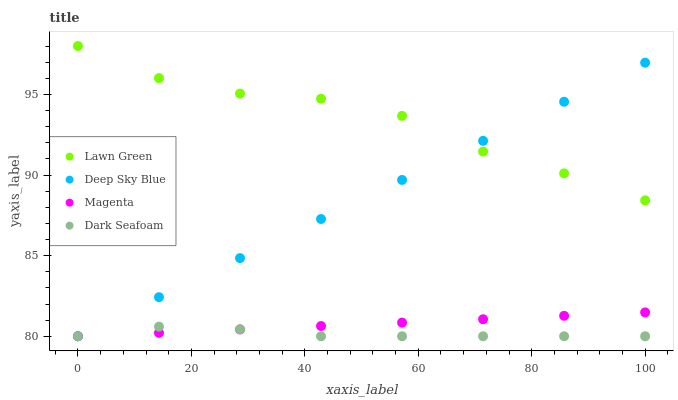Does Dark Seafoam have the minimum area under the curve?
Answer yes or no. Yes. Does Lawn Green have the maximum area under the curve?
Answer yes or no. Yes. Does Magenta have the minimum area under the curve?
Answer yes or no. No. Does Magenta have the maximum area under the curve?
Answer yes or no. No. Is Deep Sky Blue the smoothest?
Answer yes or no. Yes. Is Lawn Green the roughest?
Answer yes or no. Yes. Is Magenta the smoothest?
Answer yes or no. No. Is Magenta the roughest?
Answer yes or no. No. Does Magenta have the lowest value?
Answer yes or no. Yes. Does Lawn Green have the highest value?
Answer yes or no. Yes. Does Magenta have the highest value?
Answer yes or no. No. Is Dark Seafoam less than Lawn Green?
Answer yes or no. Yes. Is Lawn Green greater than Dark Seafoam?
Answer yes or no. Yes. Does Magenta intersect Deep Sky Blue?
Answer yes or no. Yes. Is Magenta less than Deep Sky Blue?
Answer yes or no. No. Is Magenta greater than Deep Sky Blue?
Answer yes or no. No. Does Dark Seafoam intersect Lawn Green?
Answer yes or no. No. 